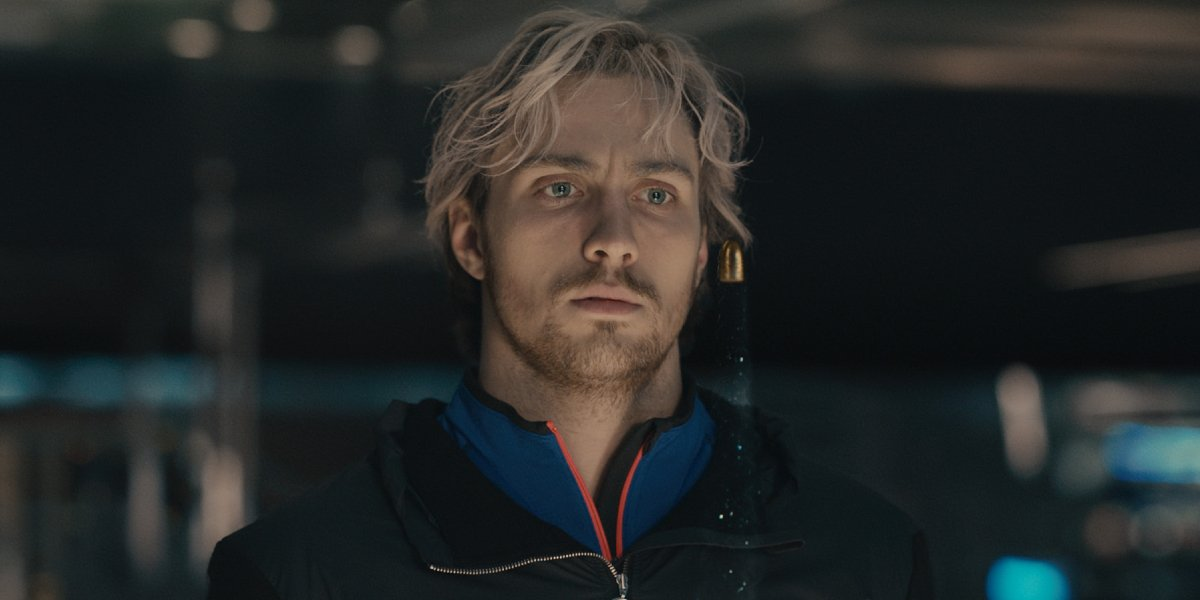Analyze the image in a comprehensive and detailed manner. In this intriguing image, a man with blonde hair and a beard stands in a dimly lit environment. He is dressed in a patterned blue and black jacket that provides a pop of color against the shadowy backdrop. The room, likely a bustling store or mall, is filled with blurred shapes and abstract colors, indicating movement and activity. The focus of the man’s gaze is outside the frame, his expression conveying a deep sense of contemplation or concentration. An ambient light softly illuminates his face, adding to the scene's atmosphere of quiet intensity. 